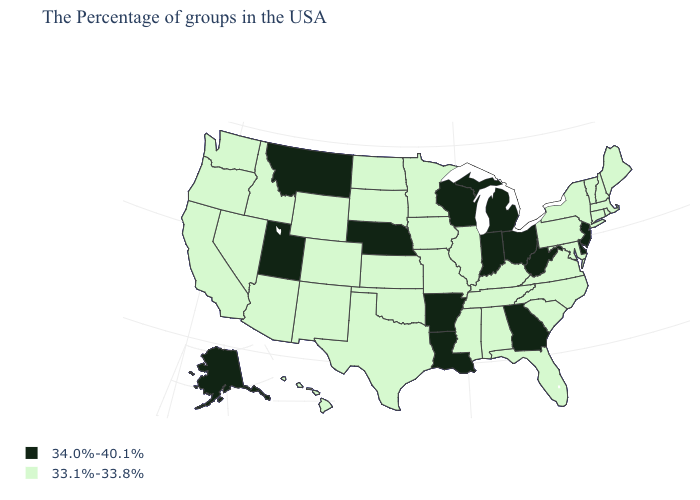What is the value of Indiana?
Concise answer only. 34.0%-40.1%. What is the value of Arizona?
Give a very brief answer. 33.1%-33.8%. Does Georgia have the highest value in the USA?
Keep it brief. Yes. How many symbols are there in the legend?
Write a very short answer. 2. Among the states that border South Dakota , does Iowa have the lowest value?
Answer briefly. Yes. Among the states that border Texas , does Oklahoma have the highest value?
Concise answer only. No. What is the lowest value in the West?
Quick response, please. 33.1%-33.8%. What is the value of Arizona?
Keep it brief. 33.1%-33.8%. What is the value of Pennsylvania?
Be succinct. 33.1%-33.8%. What is the lowest value in states that border Florida?
Short answer required. 33.1%-33.8%. Name the states that have a value in the range 33.1%-33.8%?
Write a very short answer. Maine, Massachusetts, Rhode Island, New Hampshire, Vermont, Connecticut, New York, Maryland, Pennsylvania, Virginia, North Carolina, South Carolina, Florida, Kentucky, Alabama, Tennessee, Illinois, Mississippi, Missouri, Minnesota, Iowa, Kansas, Oklahoma, Texas, South Dakota, North Dakota, Wyoming, Colorado, New Mexico, Arizona, Idaho, Nevada, California, Washington, Oregon, Hawaii. Is the legend a continuous bar?
Quick response, please. No. Among the states that border Iowa , which have the highest value?
Short answer required. Wisconsin, Nebraska. What is the value of Massachusetts?
Write a very short answer. 33.1%-33.8%. Does Kansas have the same value as Alabama?
Write a very short answer. Yes. 